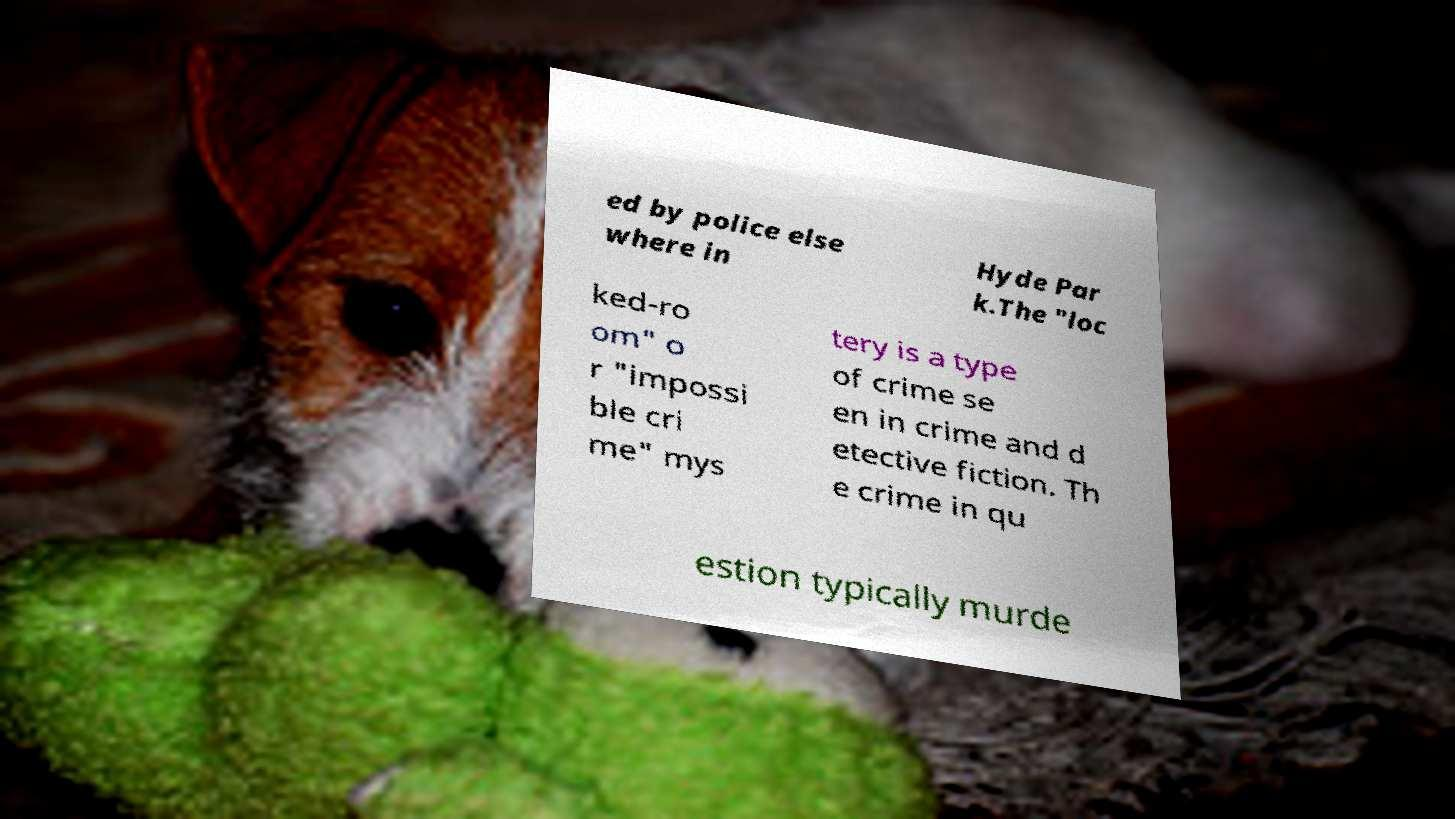What messages or text are displayed in this image? I need them in a readable, typed format. ed by police else where in Hyde Par k.The "loc ked-ro om" o r "impossi ble cri me" mys tery is a type of crime se en in crime and d etective fiction. Th e crime in qu estion typically murde 